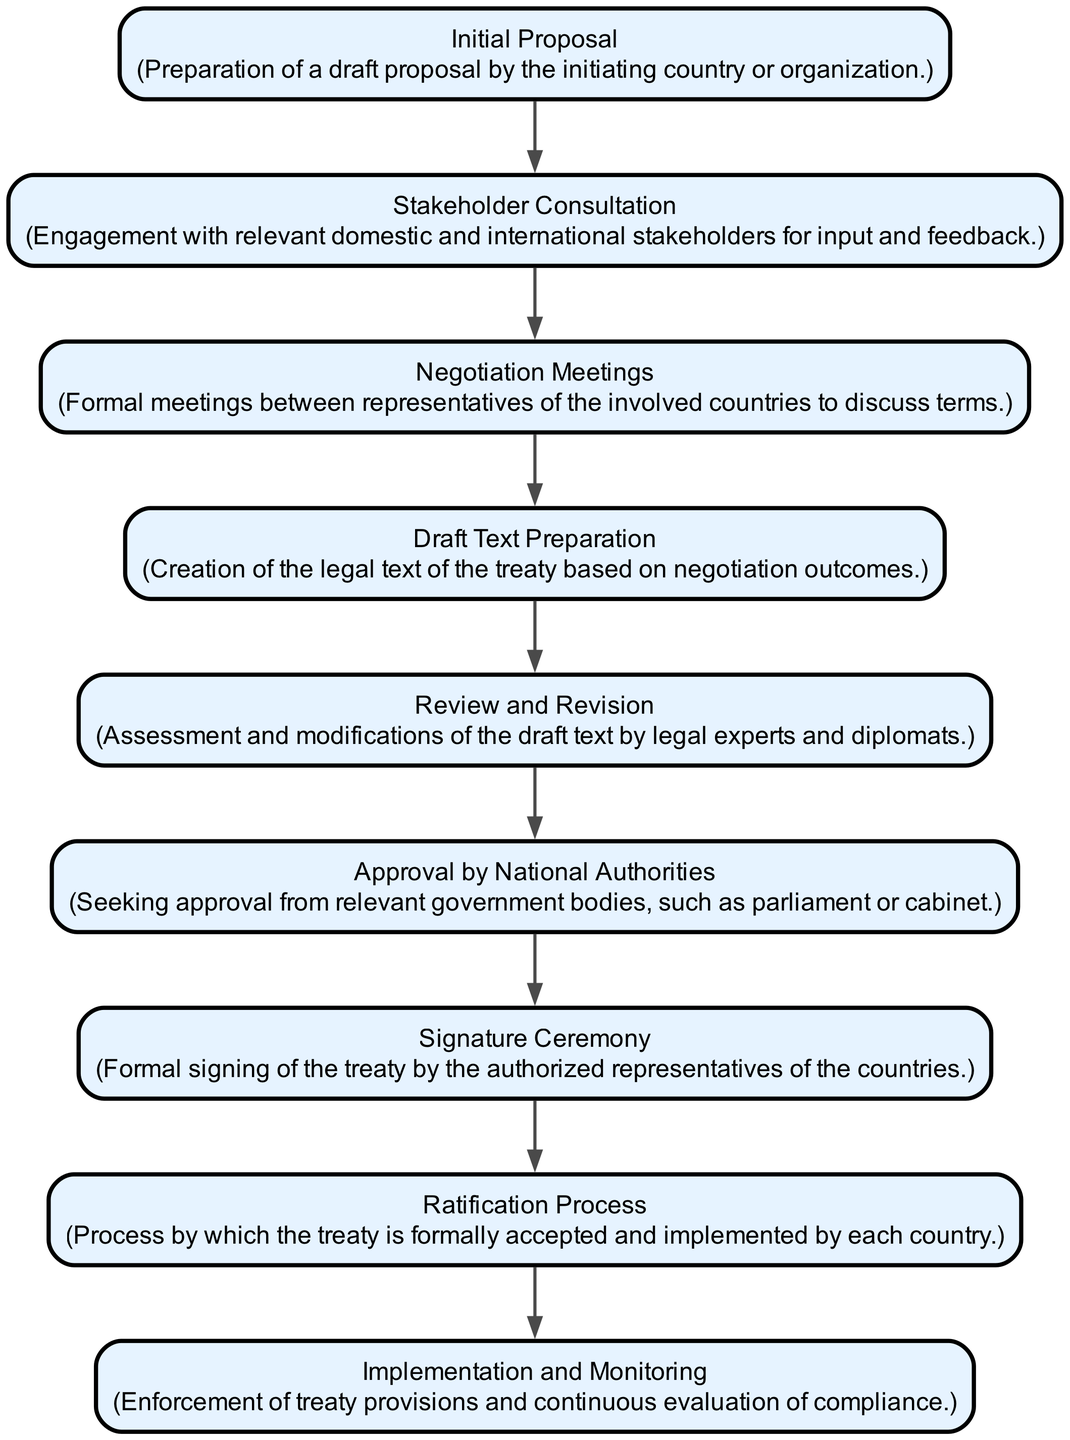What is the first step in the negotiation process? The first step in the process as shown in the diagram is "Initial Proposal," which signifies the preparation of a draft proposal by the initiating country or organization.
Answer: Initial Proposal How many steps are in the negotiation process? Counting each element in the diagram, there are nine steps outlined in the international treaty negotiation process.
Answer: Nine What follows after the "Negotiation Meetings"? Following "Negotiation Meetings," the next step in the flow is "Draft Text Preparation," indicating that the creation of the legal text occurs after formal discussions.
Answer: Draft Text Preparation Which step involves legal experts and diplomats? The "Review and Revision" step involves legal experts and diplomats who assess and modify the draft text based on previous discussions and negotiations.
Answer: Review and Revision What stage comes immediately before the "Signature Ceremony"? The stage that comes immediately before the "Signature Ceremony" is "Approval by National Authorities," meaning approval is sought from relevant government bodies before the formal signing event.
Answer: Approval by National Authorities In what step is the treaty formally accepted by each country? The step where the treaty is formally accepted and implemented by each country is known as the "Ratification Process," which is critical for the treaty to take effect legally.
Answer: Ratification Process What activity is performed in the last step of the process? The last step is "Implementation and Monitoring," which involves the enforcement of treaty provisions along with continuous evaluation of compliance with the treaty terms.
Answer: Implementation and Monitoring Is stakeholder engagement an early or late part of the process? Stakeholder Consultation is early in the process, as it engages domestic and international stakeholders for input and feedback right after the initial proposal is prepared.
Answer: Early Which step indicates the legal text creation in the negotiation flow? "Draft Text Preparation" indicates the legal text creation, occurring after negotiation meetings have taken place and terms have been discussed.
Answer: Draft Text Preparation 